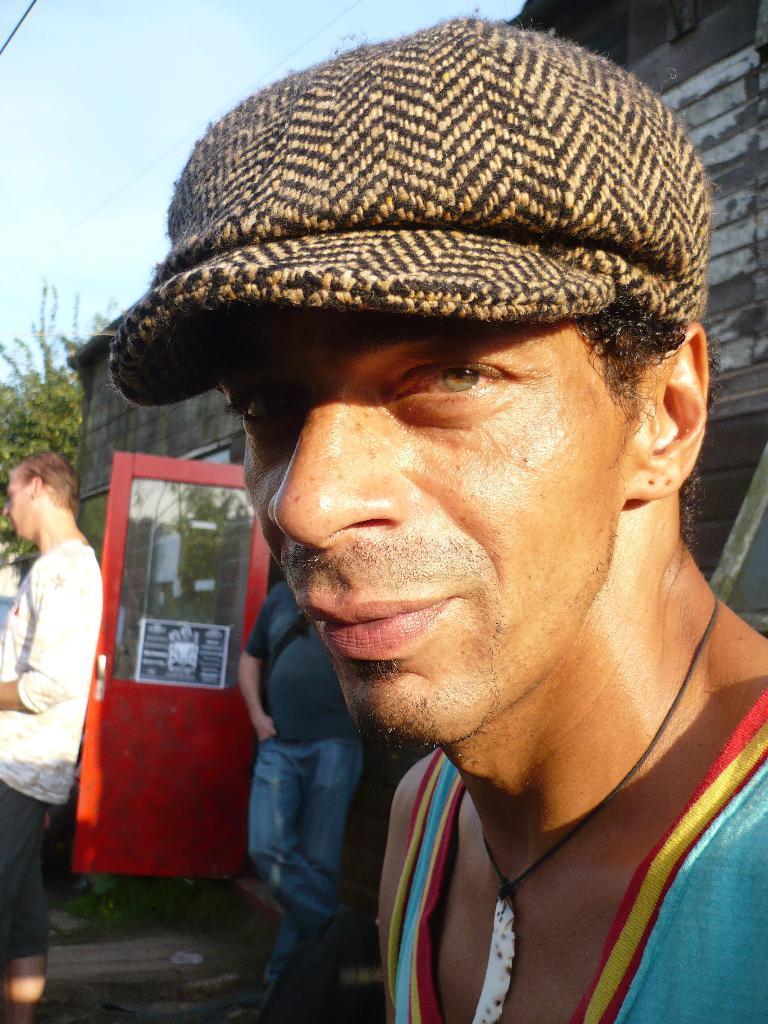How would you summarize this image in a sentence or two? The man in the front of the picture wearing blue t-shirt and black and brown cap is looking at the camera. Behind him, the man in the blue t-shirt is standing beside the red color door. Beside that, a man in white t-shirt is standing. Behind them, we see a wooden house and trees. At the top of the picture, we see the sky. 